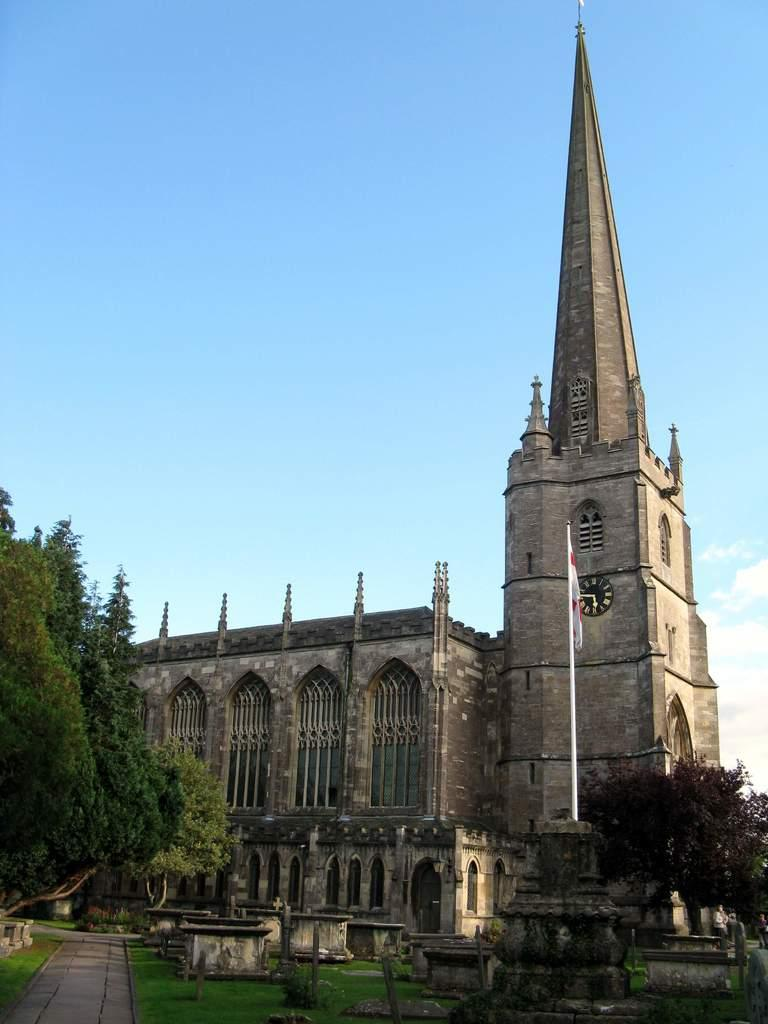What can be seen in the foreground of the image? In the foreground of the image, there is a path, grass, poles, trees, and a flag. What is located in the middle of the image? There is a building in the middle of the image. What is visible in the background of the image? The sky and clouds can be seen in the background of the image. What type of music can be heard coming from the pocket in the image? There is no pocket or music present in the image. What is the limit of the path in the image? The facts provided do not specify a limit for the path in the image. 